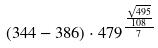<formula> <loc_0><loc_0><loc_500><loc_500>( 3 4 4 - 3 8 6 ) \cdot 4 7 9 ^ { \frac { \frac { \sqrt { 4 9 5 } } { 1 0 8 } } { 7 } }</formula> 